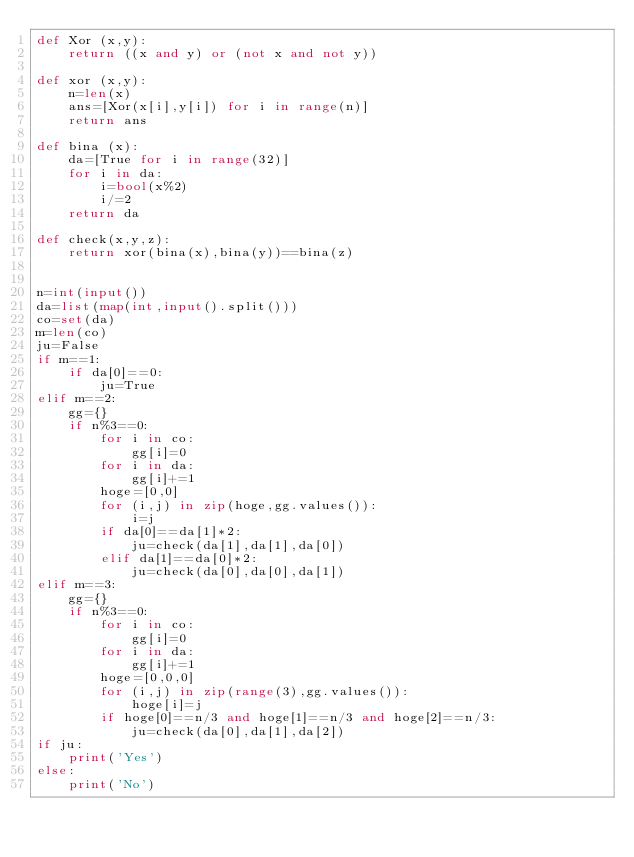Convert code to text. <code><loc_0><loc_0><loc_500><loc_500><_Python_>def Xor (x,y):
    return ((x and y) or (not x and not y))

def xor (x,y):
    n=len(x)
    ans=[Xor(x[i],y[i]) for i in range(n)]
    return ans

def bina (x):
    da=[True for i in range(32)]
    for i in da:
        i=bool(x%2)
        i/=2
    return da

def check(x,y,z):
    return xor(bina(x),bina(y))==bina(z)


n=int(input())
da=list(map(int,input().split()))
co=set(da)
m=len(co)
ju=False
if m==1:
    if da[0]==0:
        ju=True
elif m==2:
    gg={}
    if n%3==0:
        for i in co:
            gg[i]=0
        for i in da:
            gg[i]+=1
        hoge=[0,0]
        for (i,j) in zip(hoge,gg.values()):
            i=j
        if da[0]==da[1]*2:
            ju=check(da[1],da[1],da[0])
        elif da[1]==da[0]*2:
            ju=check(da[0],da[0],da[1])
elif m==3:
    gg={}
    if n%3==0:
        for i in co:
            gg[i]=0
        for i in da:
            gg[i]+=1
        hoge=[0,0,0]
        for (i,j) in zip(range(3),gg.values()):
            hoge[i]=j
        if hoge[0]==n/3 and hoge[1]==n/3 and hoge[2]==n/3:
            ju=check(da[0],da[1],da[2])
if ju:
    print('Yes')
else:
    print('No')</code> 